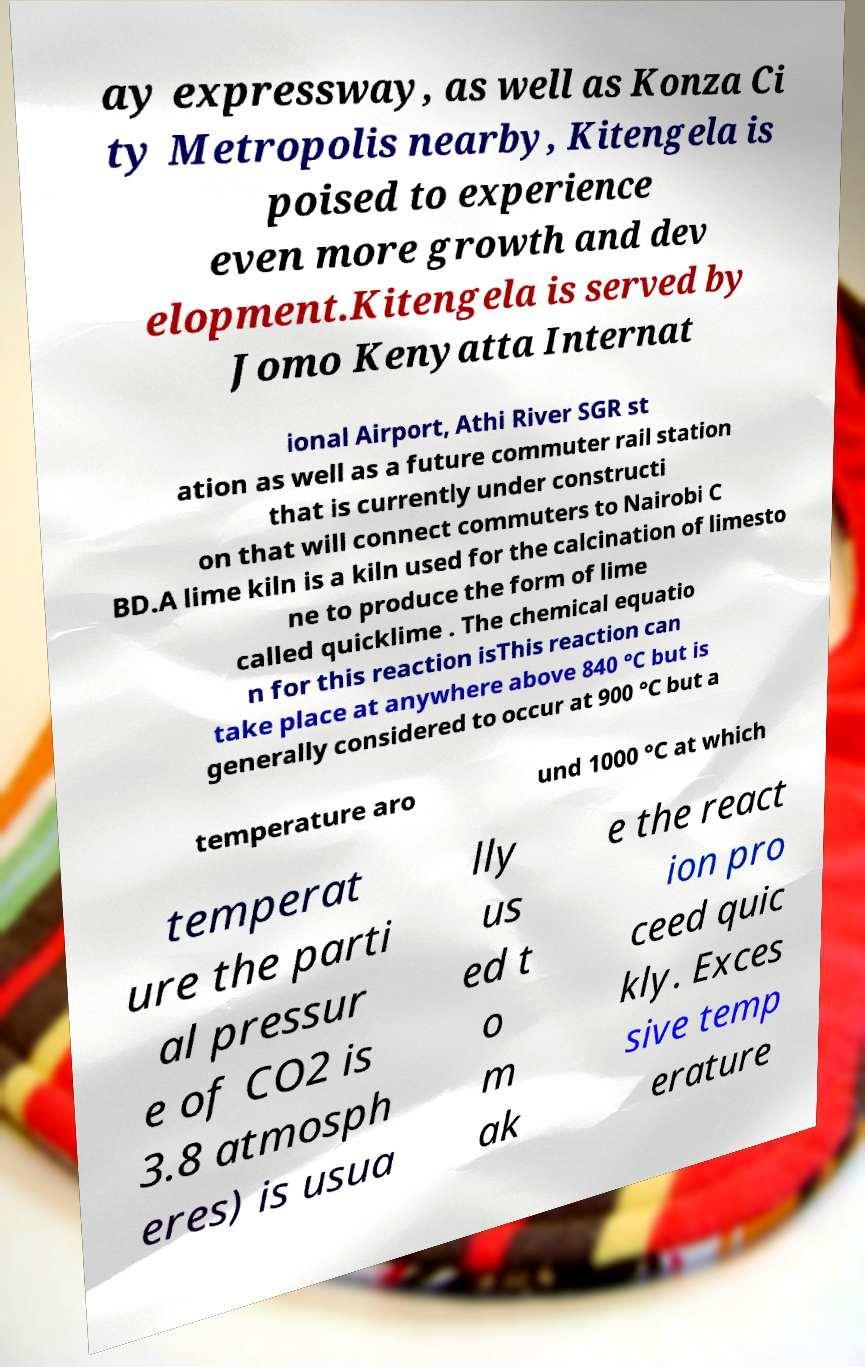What messages or text are displayed in this image? I need them in a readable, typed format. ay expressway, as well as Konza Ci ty Metropolis nearby, Kitengela is poised to experience even more growth and dev elopment.Kitengela is served by Jomo Kenyatta Internat ional Airport, Athi River SGR st ation as well as a future commuter rail station that is currently under constructi on that will connect commuters to Nairobi C BD.A lime kiln is a kiln used for the calcination of limesto ne to produce the form of lime called quicklime . The chemical equatio n for this reaction isThis reaction can take place at anywhere above 840 °C but is generally considered to occur at 900 °C but a temperature aro und 1000 °C at which temperat ure the parti al pressur e of CO2 is 3.8 atmosph eres) is usua lly us ed t o m ak e the react ion pro ceed quic kly. Exces sive temp erature 